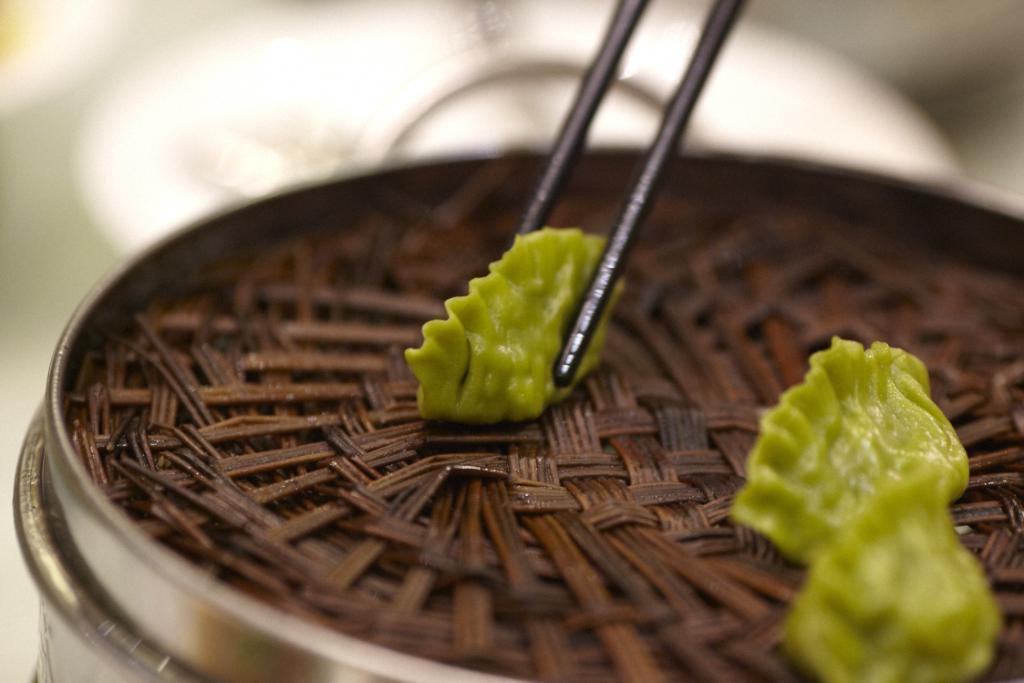Could you give a brief overview of what you see in this image? in a steamer there are 3 green moms. the left momo is held by brown chopsticks. 